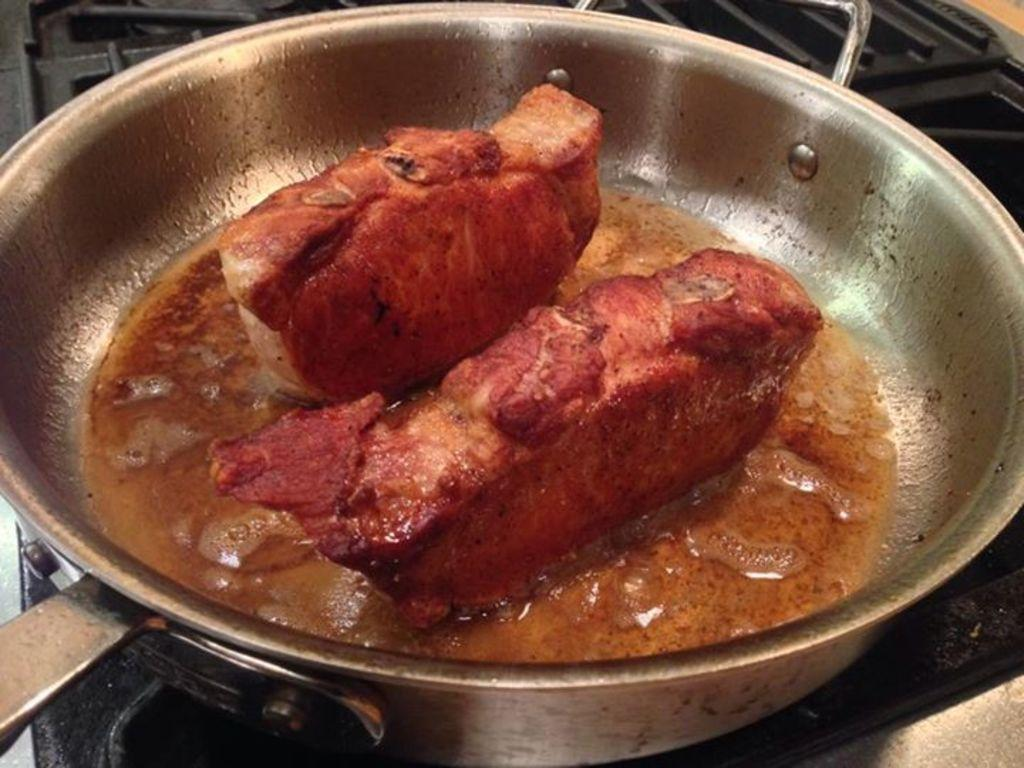What is in the pan that is visible in the image? There is food in a pan in the image. What type of slope can be seen in the image? There is no slope present in the image; it only features a pan with food. 